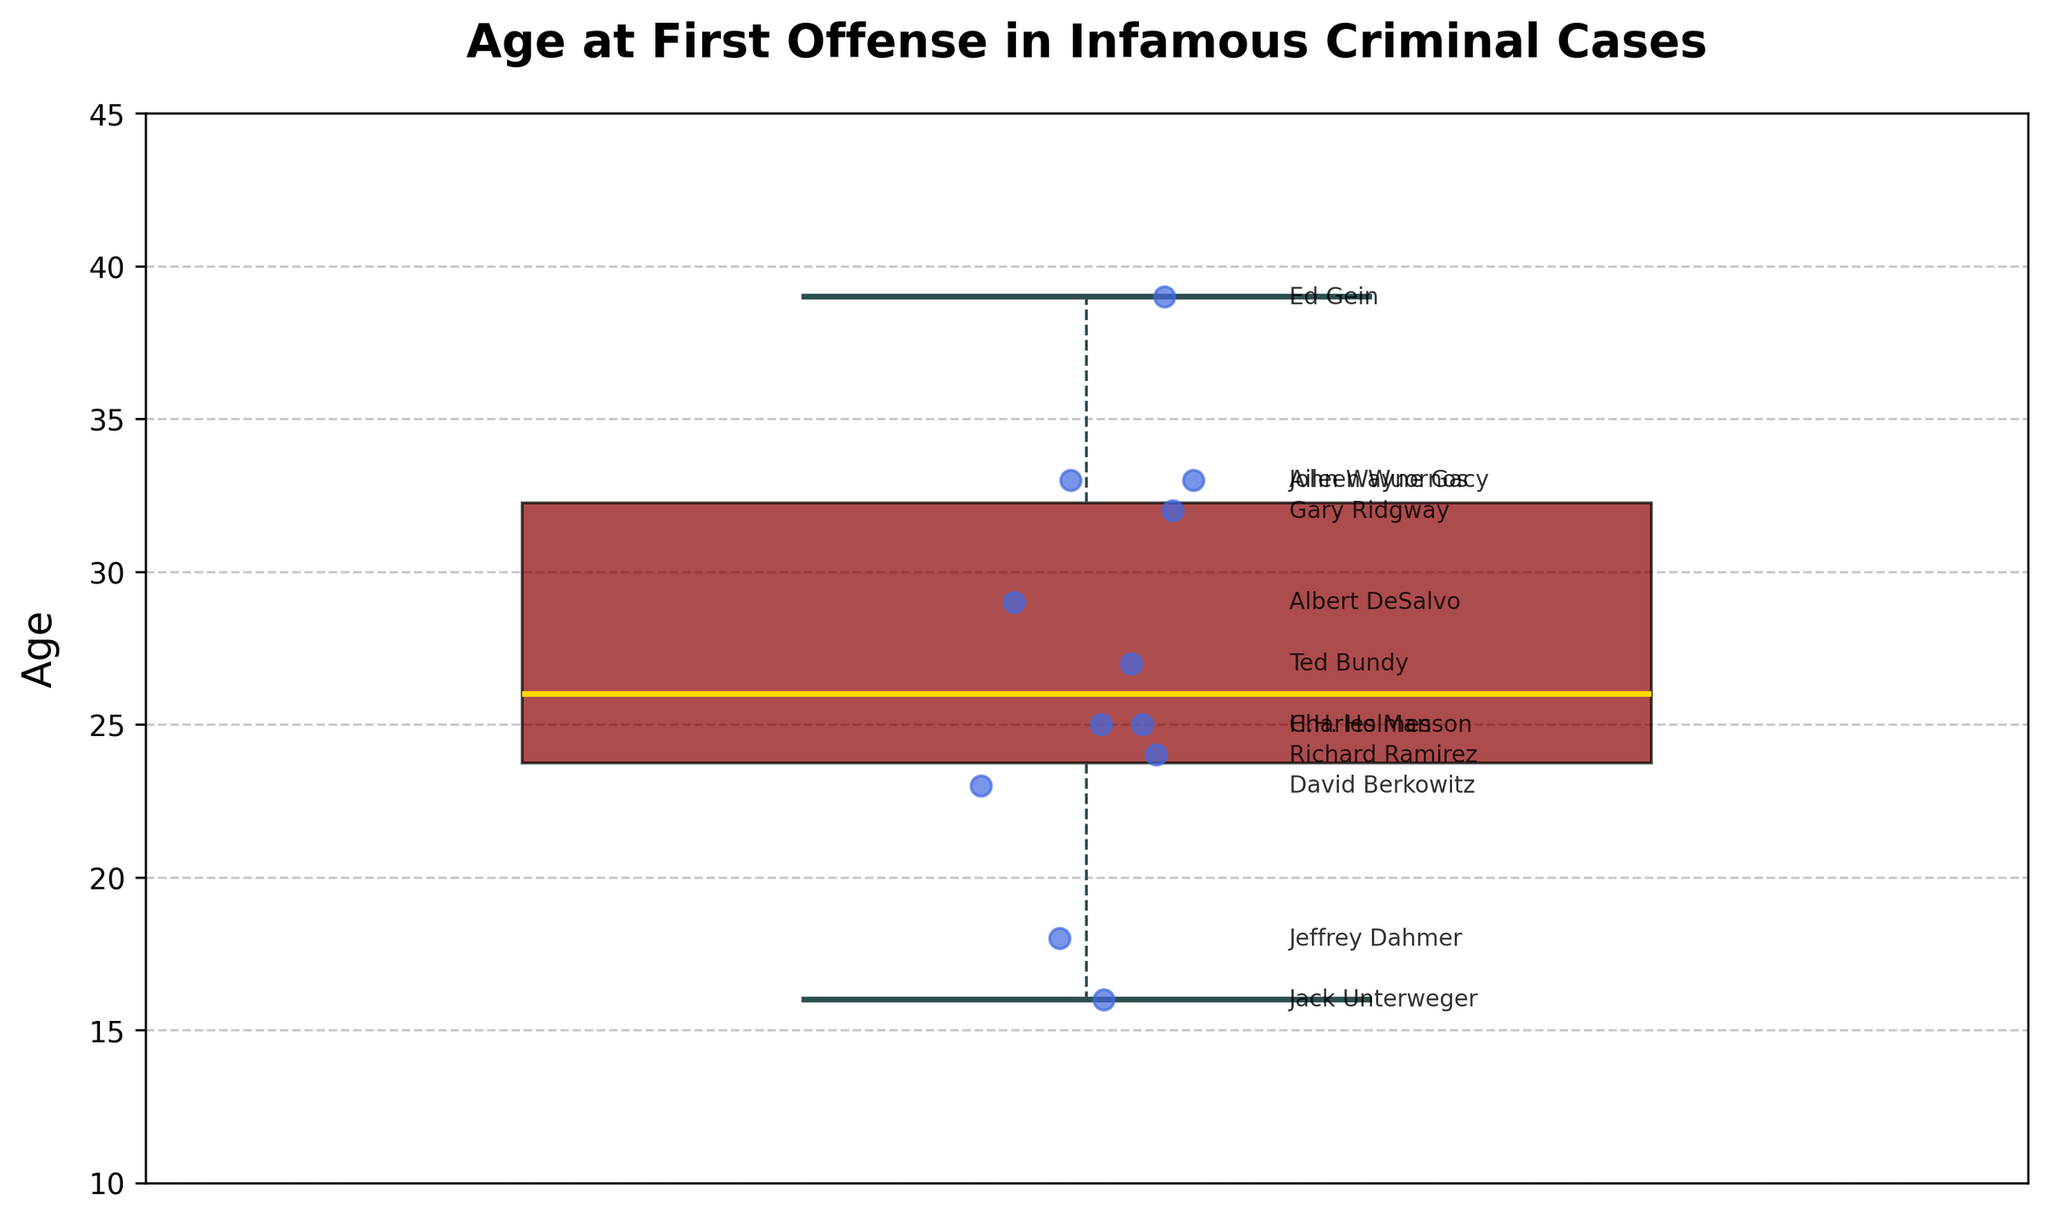How many total data points are represented in the box plot? Count the number of individual annotations or scatter points present on the plot. Each point represents a data entry, and there are 12 different criminals listed.
Answer: 12 What is the median age of the first offense among these criminals? Identify the line inside the box, which represents the median value of the dataset. From visual inspection, the median value aligns with the 25 mark on the y-axis.
Answer: 25 Which criminal has the youngest age at the first offense? Look for the lowest data point and read the corresponding label annotated next to it. The youngest age is 16, and Jack Unterweger is annotated next to this point.
Answer: Jack Unterweger What is the range of ages at the first offense among these criminals? Identify the minimum and maximum data points, which are 16 and 39, respectively. Calculate the range by subtracting the minimum from the maximum: 39 - 16.
Answer: 23 Are there any outliers in the dataset, and if so, how many? Look for any points outside the whiskers of the box plot. Outliers are often plotted individually as fliers. There are 3 fliers visible in the plot.
Answer: 3 Calculate the interquartile range (IQR) for the age at the first offense. The IQR is the difference between the third quartile (Q3) and the first quartile (Q1). From visual inspection, Q3 is around 33, and Q1 is around 23. Therefore, IQR = Q3 - Q1 = 33 - 23.
Answer: 10 Who committed their first offense at the same age as the median value in this dataset? Find the criminals whose ages align with the median value of 25. Charles Manson and H.H. Holmes are labeled at the 25 mark.
Answer: Charles Manson, H.H. Holmes Which age value occurs most frequently among the data points? Although the chart itself does not show frequency, visually count the points aligned on the same age. The age 33 has two data points (John Wayne Gacy and Aileen Wuornos) making it the most frequent.
Answer: 33 How do the whiskers represent the data distribution in this box plot? The whiskers extend from the first and third quartiles to the smallest and largest values within 1.5 * IQR of these quartiles. Points beyond this range are considered outliers. The whiskers show the spread of ages within the non-outlier range.
Answer: They represent the spread of ages within the non-outlier range What is the overall trend observed in the ages of first offenses among these criminals? The ages vary widely, with a majority clustered between 18 and 33, indicating varied onset times for criminal behavior among infamous criminals. The presence of multiple outliers suggests a skewed distribution.
Answer: Varied, with most clustered between 18 and 33 